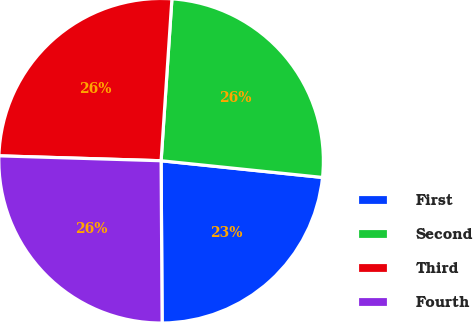<chart> <loc_0><loc_0><loc_500><loc_500><pie_chart><fcel>First<fcel>Second<fcel>Third<fcel>Fourth<nl><fcel>23.26%<fcel>25.58%<fcel>25.58%<fcel>25.58%<nl></chart> 